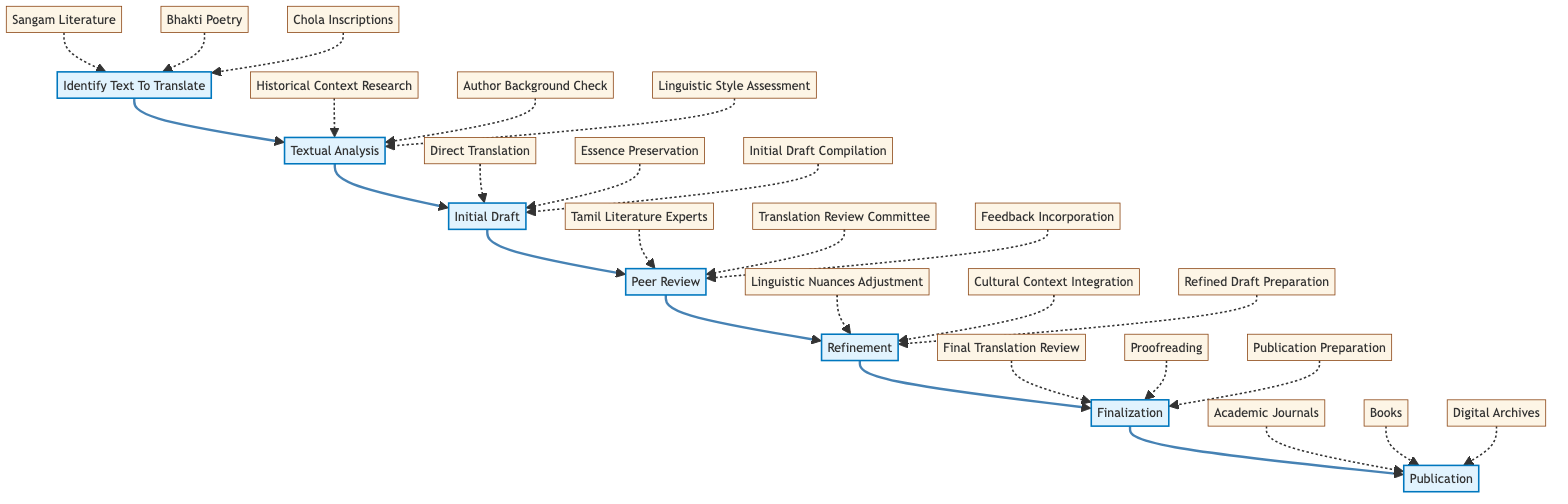What is the first step in the translation workflow? The first step in the translation workflow is "Identify Text To Translate," which is indicated as the starting node in the flow chart.
Answer: Identify Text To Translate How many types of ancient Tamil texts are identified for translation in the diagram? The diagram highlights three types of ancient Tamil texts: Sangam Literature, Bhakti Poetry, and Chola Inscriptions, as shown branching from the first step.
Answer: Three What is the purpose of the Peer Review step? The Peer Review step is focused on submitting the initial draft to experts for review and feedback, ensuring accuracy and fidelity, as described in the node definition.
Answer: Ensuring accuracy and fidelity What follows after the Refinement step? After the Refinement step, the next step is Finalization, as indicated by the flow from the Refinement node leading directly to the Finalization node.
Answer: Finalization List one of the entities involved in Textual Analysis. One of the entities involved in the Textual Analysis step is "Historical Context Research," which is specified in the related entities under the Textual Analysis node.
Answer: Historical Context Research Which step includes the adjustment of linguistic nuances? The adjustment of linguistic nuances is included in the Refinement step, which focuses on refining the translation based on feedback.
Answer: Refinement What is the last step in the translation workflow? The last step in the translation workflow is Publication, as indicated by the final node in the flow chart that follows Finalization.
Answer: Publication How many entities are associated with the refinement of the translation? There are three entities associated with the refinement of the translation: Linguistic Nuances Adjustment, Cultural Context Integration, and Refined Draft Preparation, as listed under the Refinement step.
Answer: Three What does the Finalization step prepare for? The Finalization step prepares the final version of the translation for publication or dissemination, as indicated in the node description.
Answer: Publication or dissemination 